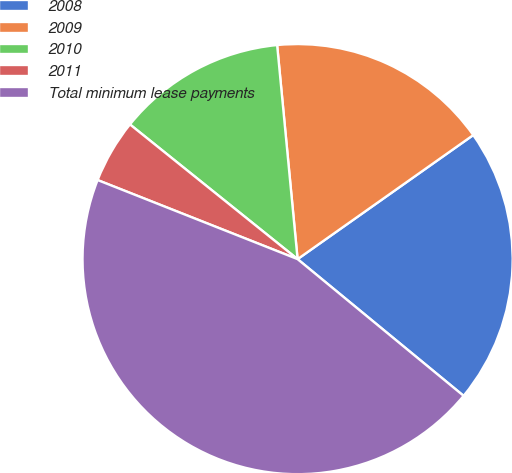<chart> <loc_0><loc_0><loc_500><loc_500><pie_chart><fcel>2008<fcel>2009<fcel>2010<fcel>2011<fcel>Total minimum lease payments<nl><fcel>20.75%<fcel>16.73%<fcel>12.71%<fcel>4.78%<fcel>45.03%<nl></chart> 